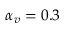<formula> <loc_0><loc_0><loc_500><loc_500>\alpha _ { v } = 0 . 3</formula> 